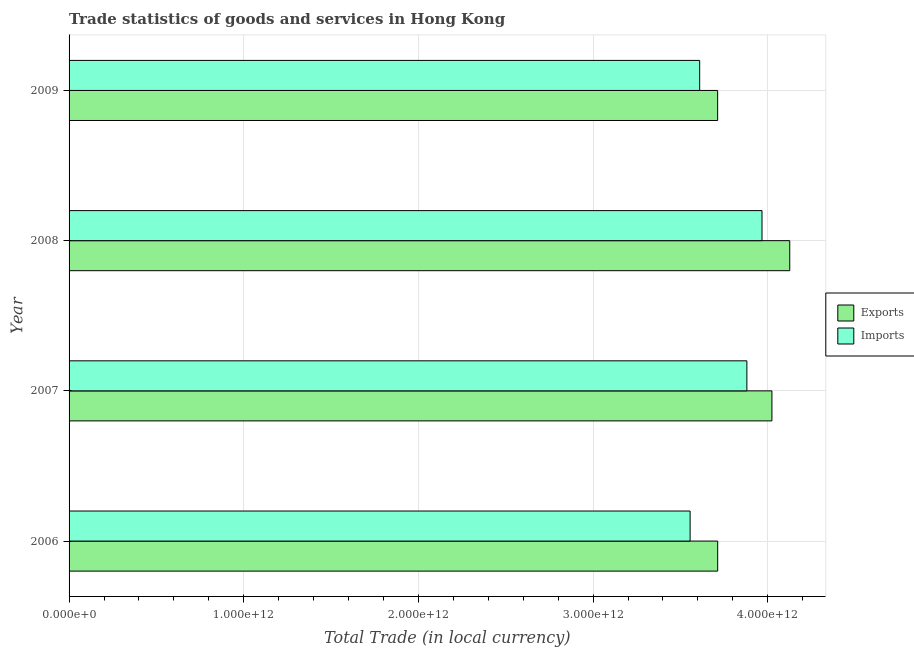How many groups of bars are there?
Offer a terse response. 4. In how many cases, is the number of bars for a given year not equal to the number of legend labels?
Provide a succinct answer. 0. What is the imports of goods and services in 2006?
Offer a very short reply. 3.56e+12. Across all years, what is the maximum imports of goods and services?
Make the answer very short. 3.97e+12. Across all years, what is the minimum imports of goods and services?
Offer a very short reply. 3.56e+12. In which year was the imports of goods and services minimum?
Provide a succinct answer. 2006. What is the total export of goods and services in the graph?
Your response must be concise. 1.56e+13. What is the difference between the export of goods and services in 2006 and that in 2009?
Keep it short and to the point. 2.45e+08. What is the difference between the export of goods and services in 2008 and the imports of goods and services in 2009?
Your response must be concise. 5.16e+11. What is the average export of goods and services per year?
Your answer should be very brief. 3.89e+12. In the year 2006, what is the difference between the imports of goods and services and export of goods and services?
Give a very brief answer. -1.58e+11. In how many years, is the imports of goods and services greater than 2000000000000 LCU?
Your answer should be compact. 4. Is the imports of goods and services in 2006 less than that in 2007?
Make the answer very short. Yes. What is the difference between the highest and the second highest imports of goods and services?
Offer a very short reply. 8.67e+1. What is the difference between the highest and the lowest export of goods and services?
Provide a short and direct response. 4.13e+11. What does the 1st bar from the top in 2009 represents?
Make the answer very short. Imports. What does the 1st bar from the bottom in 2006 represents?
Ensure brevity in your answer.  Exports. What is the difference between two consecutive major ticks on the X-axis?
Provide a short and direct response. 1.00e+12. Are the values on the major ticks of X-axis written in scientific E-notation?
Provide a succinct answer. Yes. Where does the legend appear in the graph?
Your answer should be very brief. Center right. How many legend labels are there?
Provide a succinct answer. 2. What is the title of the graph?
Make the answer very short. Trade statistics of goods and services in Hong Kong. Does "Enforce a contract" appear as one of the legend labels in the graph?
Your answer should be very brief. No. What is the label or title of the X-axis?
Ensure brevity in your answer.  Total Trade (in local currency). What is the label or title of the Y-axis?
Offer a terse response. Year. What is the Total Trade (in local currency) in Exports in 2006?
Provide a succinct answer. 3.71e+12. What is the Total Trade (in local currency) in Imports in 2006?
Provide a short and direct response. 3.56e+12. What is the Total Trade (in local currency) in Exports in 2007?
Offer a terse response. 4.02e+12. What is the Total Trade (in local currency) in Imports in 2007?
Ensure brevity in your answer.  3.88e+12. What is the Total Trade (in local currency) of Exports in 2008?
Make the answer very short. 4.13e+12. What is the Total Trade (in local currency) of Imports in 2008?
Give a very brief answer. 3.97e+12. What is the Total Trade (in local currency) in Exports in 2009?
Give a very brief answer. 3.71e+12. What is the Total Trade (in local currency) in Imports in 2009?
Your answer should be very brief. 3.61e+12. Across all years, what is the maximum Total Trade (in local currency) of Exports?
Your answer should be compact. 4.13e+12. Across all years, what is the maximum Total Trade (in local currency) of Imports?
Make the answer very short. 3.97e+12. Across all years, what is the minimum Total Trade (in local currency) in Exports?
Make the answer very short. 3.71e+12. Across all years, what is the minimum Total Trade (in local currency) in Imports?
Offer a terse response. 3.56e+12. What is the total Total Trade (in local currency) of Exports in the graph?
Offer a terse response. 1.56e+13. What is the total Total Trade (in local currency) of Imports in the graph?
Keep it short and to the point. 1.50e+13. What is the difference between the Total Trade (in local currency) in Exports in 2006 and that in 2007?
Keep it short and to the point. -3.10e+11. What is the difference between the Total Trade (in local currency) of Imports in 2006 and that in 2007?
Your answer should be very brief. -3.25e+11. What is the difference between the Total Trade (in local currency) of Exports in 2006 and that in 2008?
Make the answer very short. -4.13e+11. What is the difference between the Total Trade (in local currency) in Imports in 2006 and that in 2008?
Your response must be concise. -4.12e+11. What is the difference between the Total Trade (in local currency) of Exports in 2006 and that in 2009?
Your response must be concise. 2.45e+08. What is the difference between the Total Trade (in local currency) of Imports in 2006 and that in 2009?
Your answer should be very brief. -5.48e+1. What is the difference between the Total Trade (in local currency) of Exports in 2007 and that in 2008?
Your answer should be very brief. -1.02e+11. What is the difference between the Total Trade (in local currency) of Imports in 2007 and that in 2008?
Give a very brief answer. -8.67e+1. What is the difference between the Total Trade (in local currency) of Exports in 2007 and that in 2009?
Provide a succinct answer. 3.11e+11. What is the difference between the Total Trade (in local currency) of Imports in 2007 and that in 2009?
Your answer should be very brief. 2.70e+11. What is the difference between the Total Trade (in local currency) in Exports in 2008 and that in 2009?
Your answer should be compact. 4.13e+11. What is the difference between the Total Trade (in local currency) of Imports in 2008 and that in 2009?
Keep it short and to the point. 3.57e+11. What is the difference between the Total Trade (in local currency) of Exports in 2006 and the Total Trade (in local currency) of Imports in 2007?
Give a very brief answer. -1.67e+11. What is the difference between the Total Trade (in local currency) in Exports in 2006 and the Total Trade (in local currency) in Imports in 2008?
Your answer should be very brief. -2.54e+11. What is the difference between the Total Trade (in local currency) of Exports in 2006 and the Total Trade (in local currency) of Imports in 2009?
Make the answer very short. 1.03e+11. What is the difference between the Total Trade (in local currency) in Exports in 2007 and the Total Trade (in local currency) in Imports in 2008?
Provide a short and direct response. 5.68e+1. What is the difference between the Total Trade (in local currency) of Exports in 2007 and the Total Trade (in local currency) of Imports in 2009?
Offer a very short reply. 4.14e+11. What is the difference between the Total Trade (in local currency) of Exports in 2008 and the Total Trade (in local currency) of Imports in 2009?
Keep it short and to the point. 5.16e+11. What is the average Total Trade (in local currency) of Exports per year?
Provide a short and direct response. 3.89e+12. What is the average Total Trade (in local currency) in Imports per year?
Provide a succinct answer. 3.75e+12. In the year 2006, what is the difference between the Total Trade (in local currency) in Exports and Total Trade (in local currency) in Imports?
Provide a short and direct response. 1.58e+11. In the year 2007, what is the difference between the Total Trade (in local currency) of Exports and Total Trade (in local currency) of Imports?
Your answer should be compact. 1.43e+11. In the year 2008, what is the difference between the Total Trade (in local currency) in Exports and Total Trade (in local currency) in Imports?
Make the answer very short. 1.59e+11. In the year 2009, what is the difference between the Total Trade (in local currency) of Exports and Total Trade (in local currency) of Imports?
Provide a short and direct response. 1.03e+11. What is the ratio of the Total Trade (in local currency) of Exports in 2006 to that in 2007?
Ensure brevity in your answer.  0.92. What is the ratio of the Total Trade (in local currency) of Imports in 2006 to that in 2007?
Your response must be concise. 0.92. What is the ratio of the Total Trade (in local currency) in Imports in 2006 to that in 2008?
Keep it short and to the point. 0.9. What is the ratio of the Total Trade (in local currency) in Imports in 2006 to that in 2009?
Provide a succinct answer. 0.98. What is the ratio of the Total Trade (in local currency) in Exports in 2007 to that in 2008?
Your answer should be compact. 0.98. What is the ratio of the Total Trade (in local currency) in Imports in 2007 to that in 2008?
Offer a very short reply. 0.98. What is the ratio of the Total Trade (in local currency) in Exports in 2007 to that in 2009?
Your response must be concise. 1.08. What is the ratio of the Total Trade (in local currency) in Imports in 2007 to that in 2009?
Your answer should be compact. 1.07. What is the ratio of the Total Trade (in local currency) of Exports in 2008 to that in 2009?
Offer a very short reply. 1.11. What is the ratio of the Total Trade (in local currency) in Imports in 2008 to that in 2009?
Keep it short and to the point. 1.1. What is the difference between the highest and the second highest Total Trade (in local currency) in Exports?
Your answer should be compact. 1.02e+11. What is the difference between the highest and the second highest Total Trade (in local currency) in Imports?
Give a very brief answer. 8.67e+1. What is the difference between the highest and the lowest Total Trade (in local currency) in Exports?
Offer a terse response. 4.13e+11. What is the difference between the highest and the lowest Total Trade (in local currency) of Imports?
Offer a very short reply. 4.12e+11. 